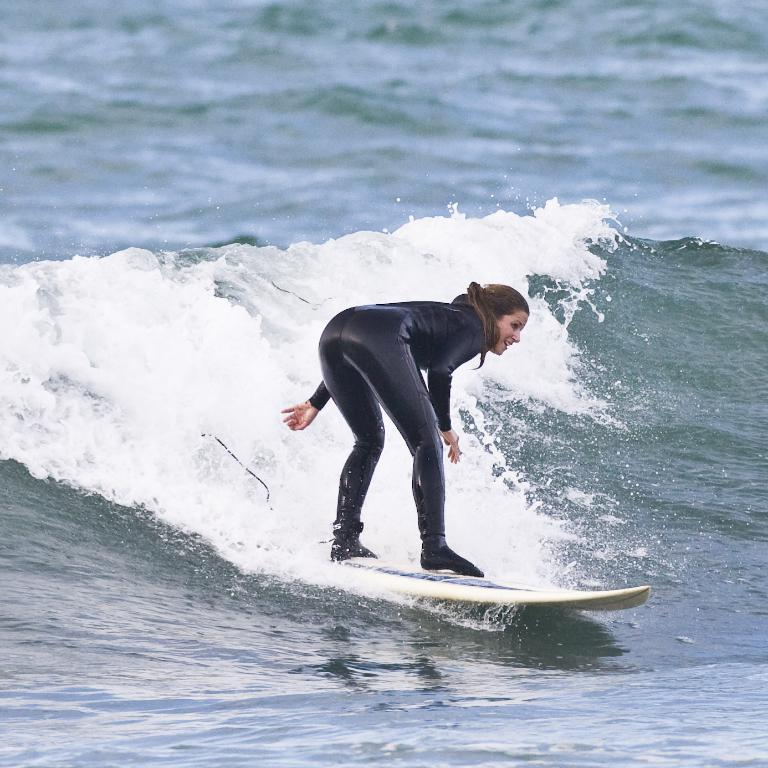Who is the main subject in the image? There is a lady in the image. What is the lady doing in the image? The lady is surfing on a surfing board. What can be seen at the bottom of the image? There is water at the bottom of the image. What type of scent can be smelled from the lady's pen in the image? There is no pen present in the image, so it is not possible to determine any scent associated with it. 